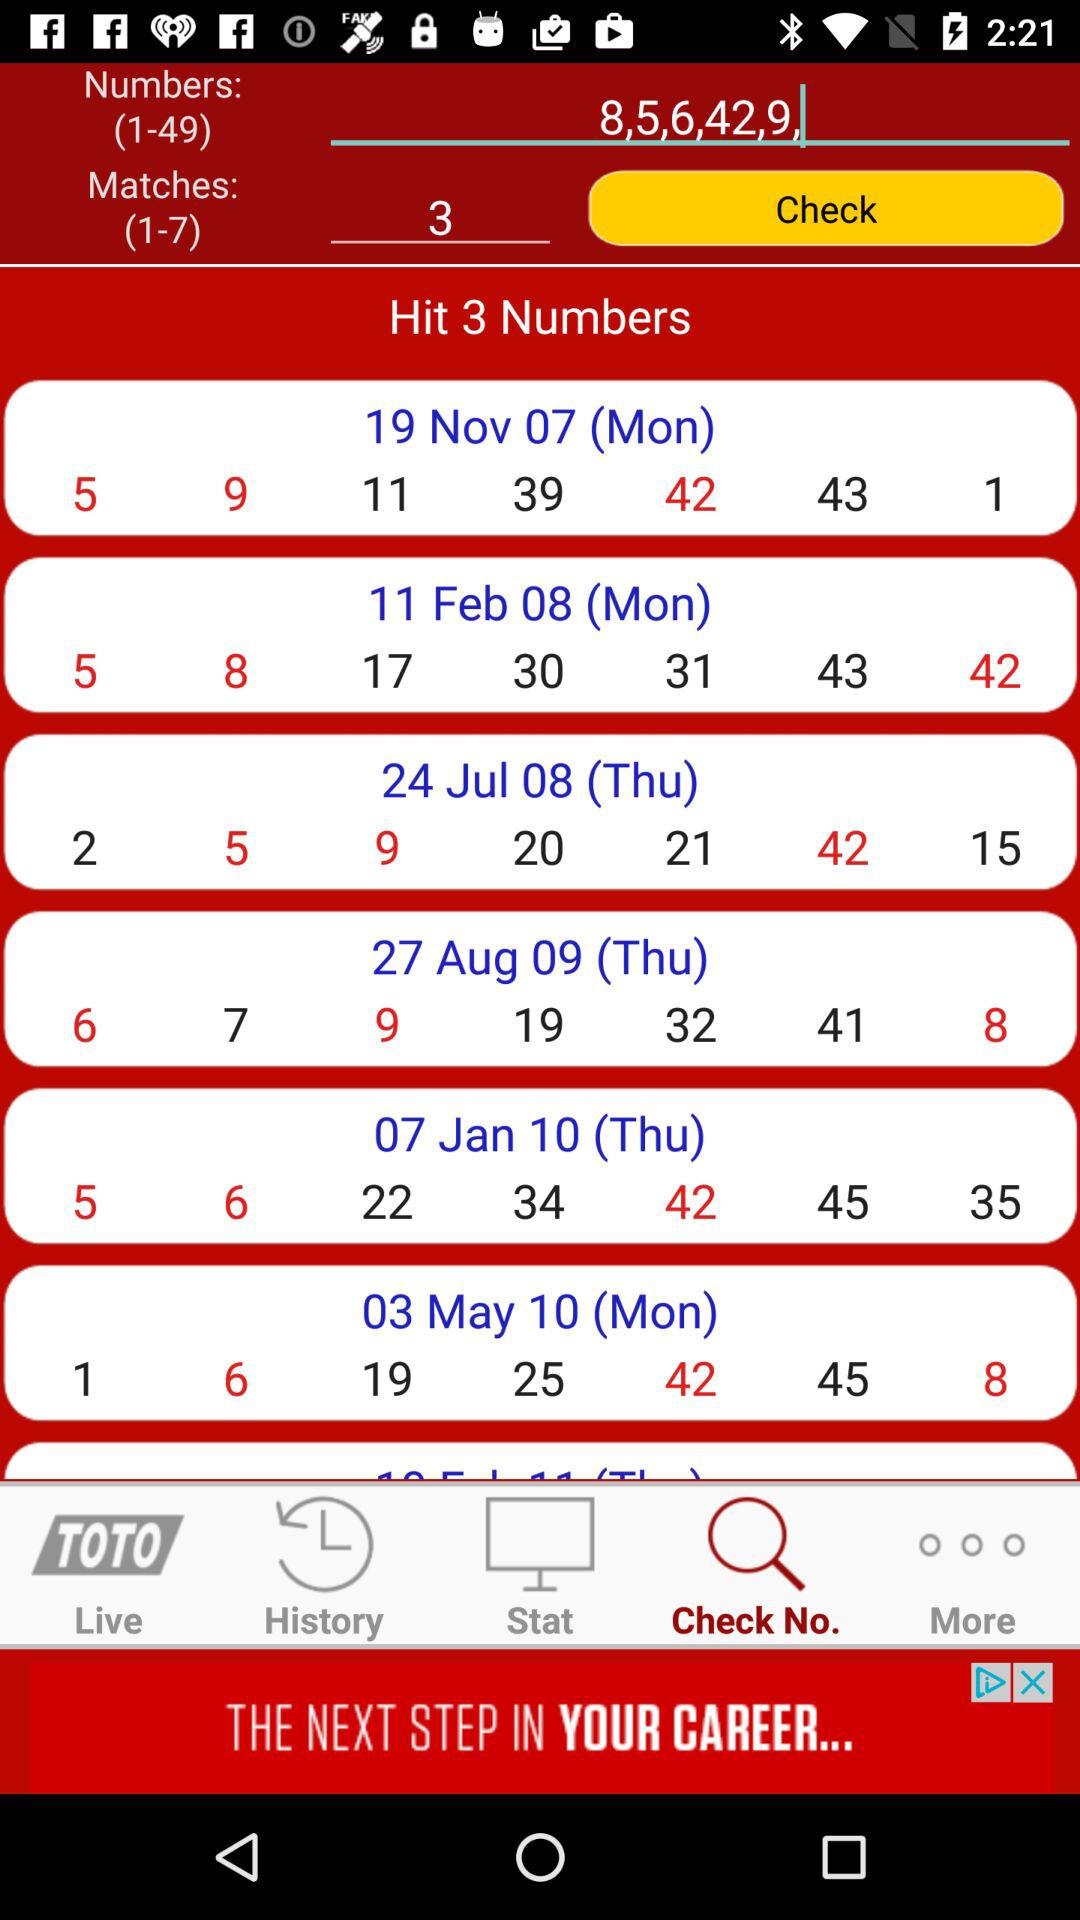What tab is selected? The selected tab is "Check No.". 